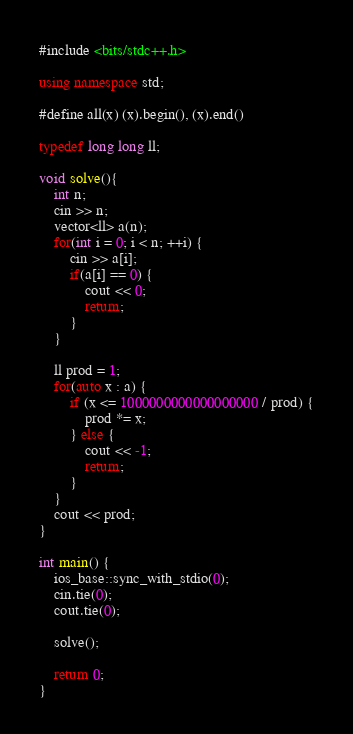<code> <loc_0><loc_0><loc_500><loc_500><_C++_>#include <bits/stdc++.h>

using namespace std;

#define all(x) (x).begin(), (x).end()

typedef long long ll;

void solve(){
	int n;
	cin >> n;
	vector<ll> a(n);
	for(int i = 0; i < n; ++i) {
		cin >> a[i];
		if(a[i] == 0) {
			cout << 0;
			return;
		}
	}
	
	ll prod = 1;
	for(auto x : a) {
		if (x <= 1000000000000000000 / prod) {
			prod *= x;
		} else {
			cout << -1;
			return;
		}
	}
	cout << prod;
}

int main() {
    ios_base::sync_with_stdio(0);
    cin.tie(0);
    cout.tie(0);

	solve();
    
    return 0;
}
</code> 